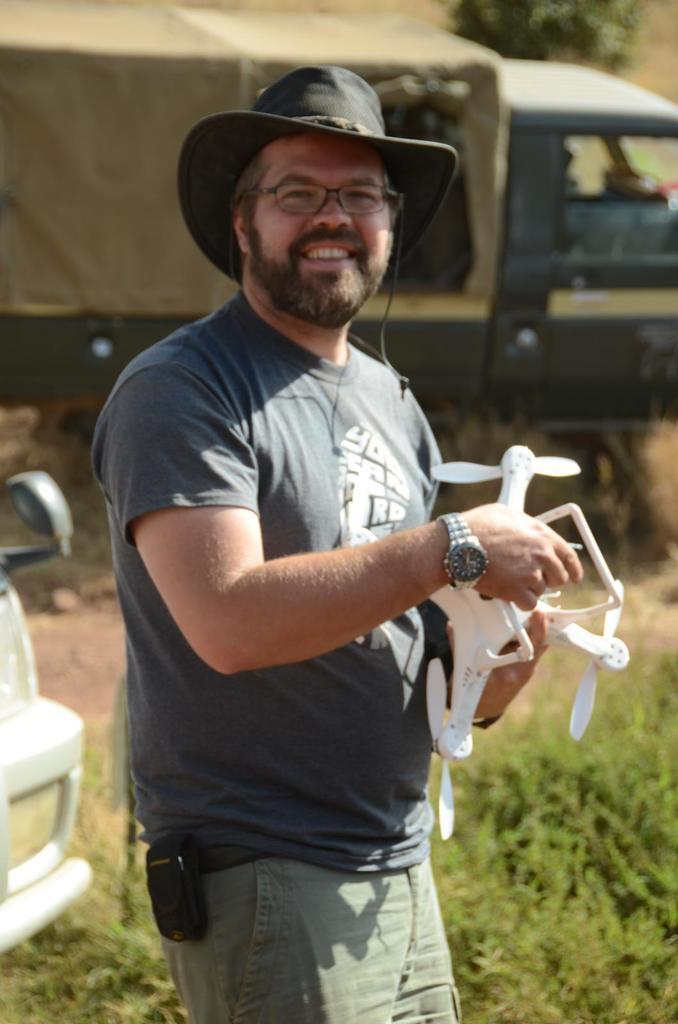Please provide a concise description of this image. In the image there is a man with a hat and spectacles. He is standing and holding a drone in his hand. Behind him there is a vehicle. And on the left side corner of the image there is another vehicle. 